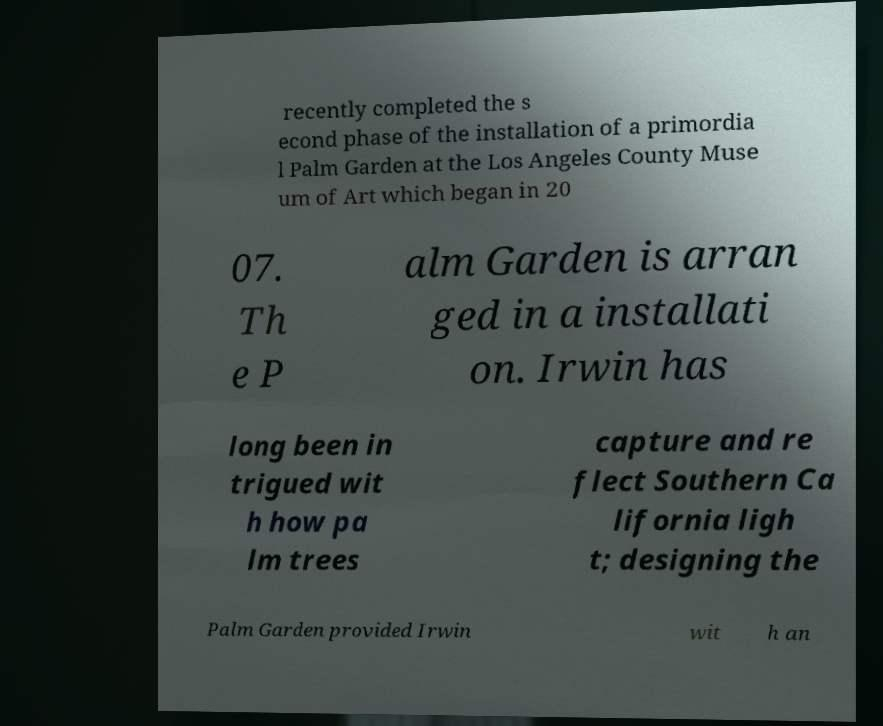There's text embedded in this image that I need extracted. Can you transcribe it verbatim? recently completed the s econd phase of the installation of a primordia l Palm Garden at the Los Angeles County Muse um of Art which began in 20 07. Th e P alm Garden is arran ged in a installati on. Irwin has long been in trigued wit h how pa lm trees capture and re flect Southern Ca lifornia ligh t; designing the Palm Garden provided Irwin wit h an 